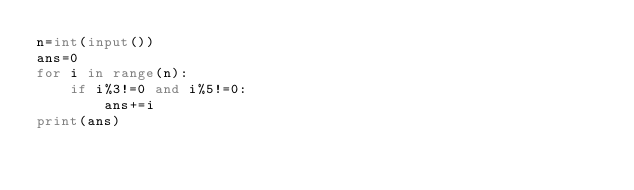Convert code to text. <code><loc_0><loc_0><loc_500><loc_500><_Python_>n=int(input())
ans=0
for i in range(n):
    if i%3!=0 and i%5!=0:
        ans+=i
print(ans)</code> 